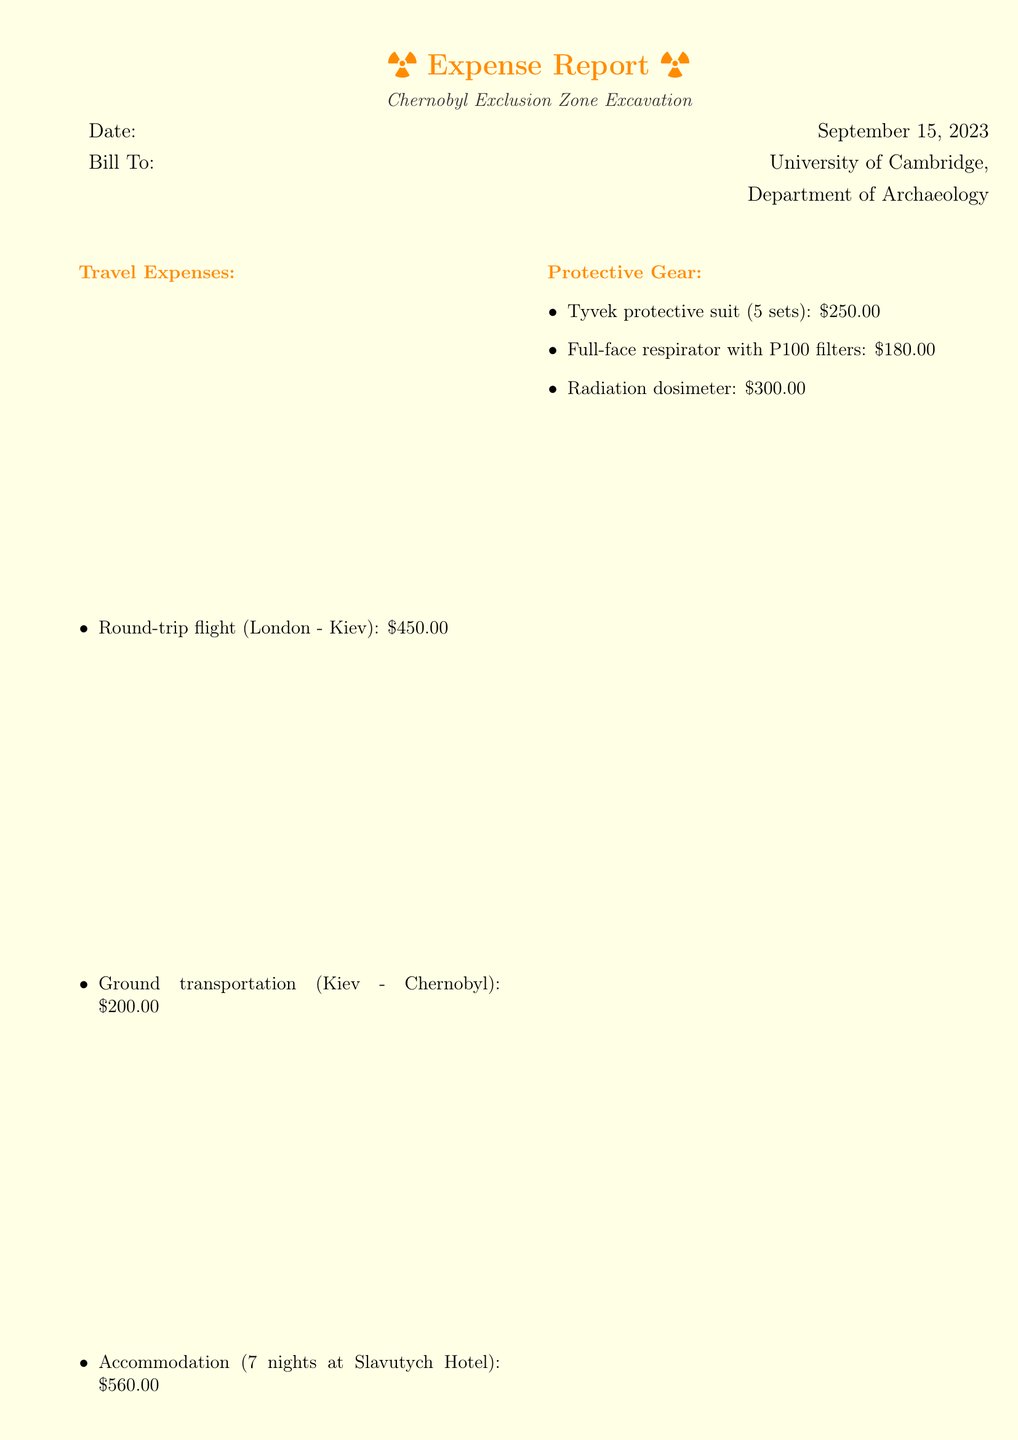What is the date of the expense report? The date of the expense report is explicitly stated in the document.
Answer: September 15, 2023 Who is the bill addressed to? The document specifies who the bill is billed to in the "Bill To" section.
Answer: University of Cambridge, Department of Archaeology What is the cost of round-trip flight to Kiev? The document lists the cost of the round-trip flight in the travel expenses section.
Answer: $450.00 How many nights of accommodation are included in the bill? The number of nights is mentioned in the accommodation item under travel expenses.
Answer: 7 nights What is the total cost of the expenses? The total cost is calculated and presented at the end of the document.
Answer: $2,670.00 What type of protective gear is mentioned? The types of protective gear are listed in the document.
Answer: Tyvek protective suit, Full-face respirator, Radiation dosimeter What is the purpose of the additional notes? The additional notes provide context for the research and funding source associated with the expenses.
Answer: To inform about the research project 'Long-term Effects of Radiation on Archaeological Artifacts' How much does it cost to rent a Geiger counter? The cost of the Geiger counter rental is clearly defined in the miscellaneous expenses section.
Answer: $150.00 What is the daily cost of the on-site decontamination shower? The document specifies the daily cost of the on-site decontamination shower in the decontamination services section.
Answer: $350.00 